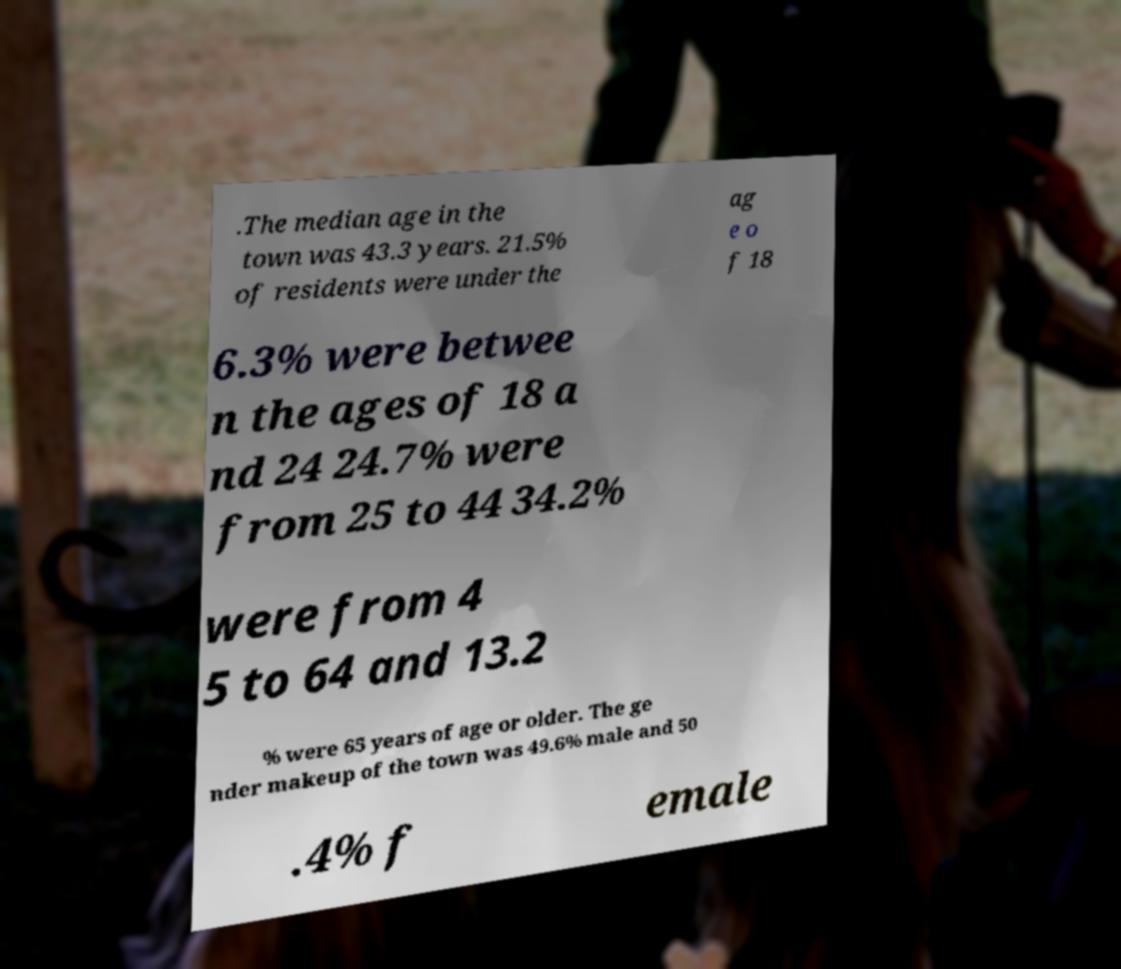Please identify and transcribe the text found in this image. .The median age in the town was 43.3 years. 21.5% of residents were under the ag e o f 18 6.3% were betwee n the ages of 18 a nd 24 24.7% were from 25 to 44 34.2% were from 4 5 to 64 and 13.2 % were 65 years of age or older. The ge nder makeup of the town was 49.6% male and 50 .4% f emale 